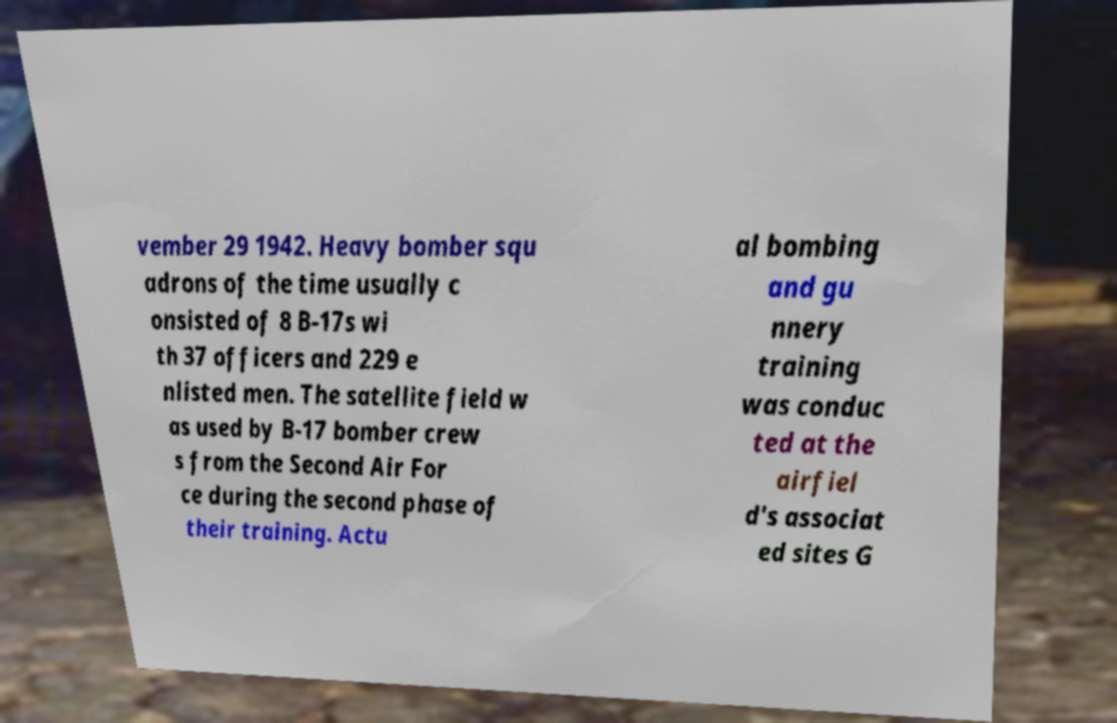For documentation purposes, I need the text within this image transcribed. Could you provide that? vember 29 1942. Heavy bomber squ adrons of the time usually c onsisted of 8 B-17s wi th 37 officers and 229 e nlisted men. The satellite field w as used by B-17 bomber crew s from the Second Air For ce during the second phase of their training. Actu al bombing and gu nnery training was conduc ted at the airfiel d's associat ed sites G 